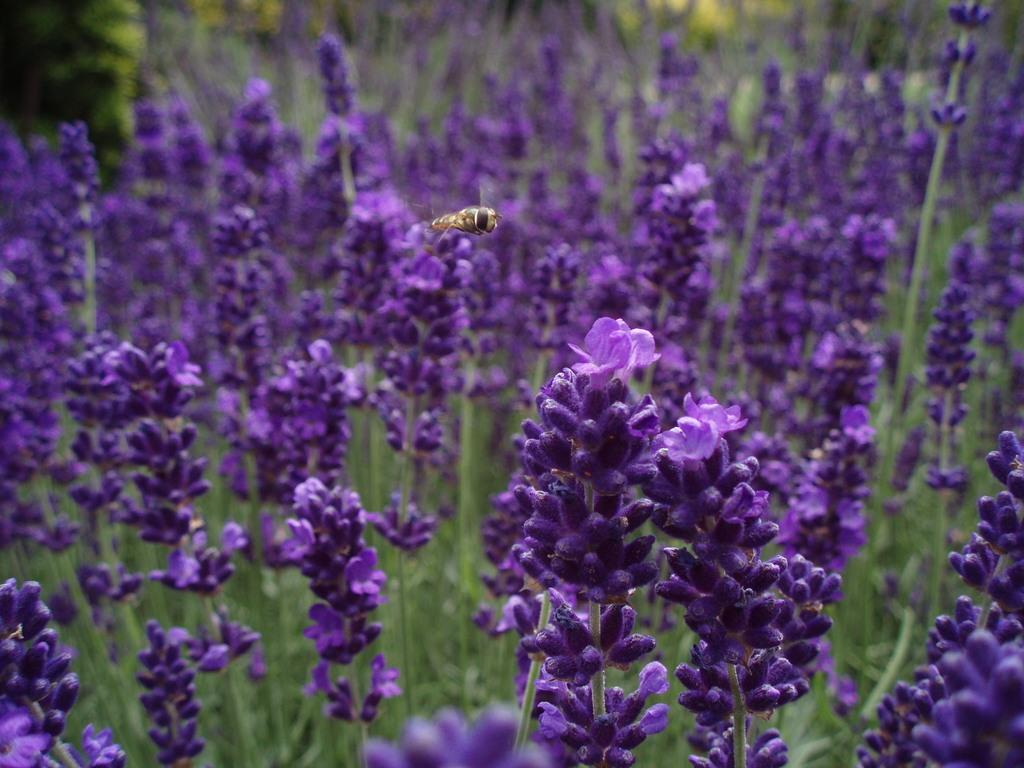What type of flowers can be seen in the image? There are purple flowers in the image. What is happening in the air in the image? There is an insect flying in the air in the image. What can be seen in the distance in the image? There are trees visible in the background of the image. How would you describe the appearance of the background? The background appears blurry. How many ants are crawling on the stitch in the image? There are no ants or stitches present in the image. In which direction is the image facing, north or south? The image does not have a specific direction, as it is a still image and not a photograph taken from a particular location. 